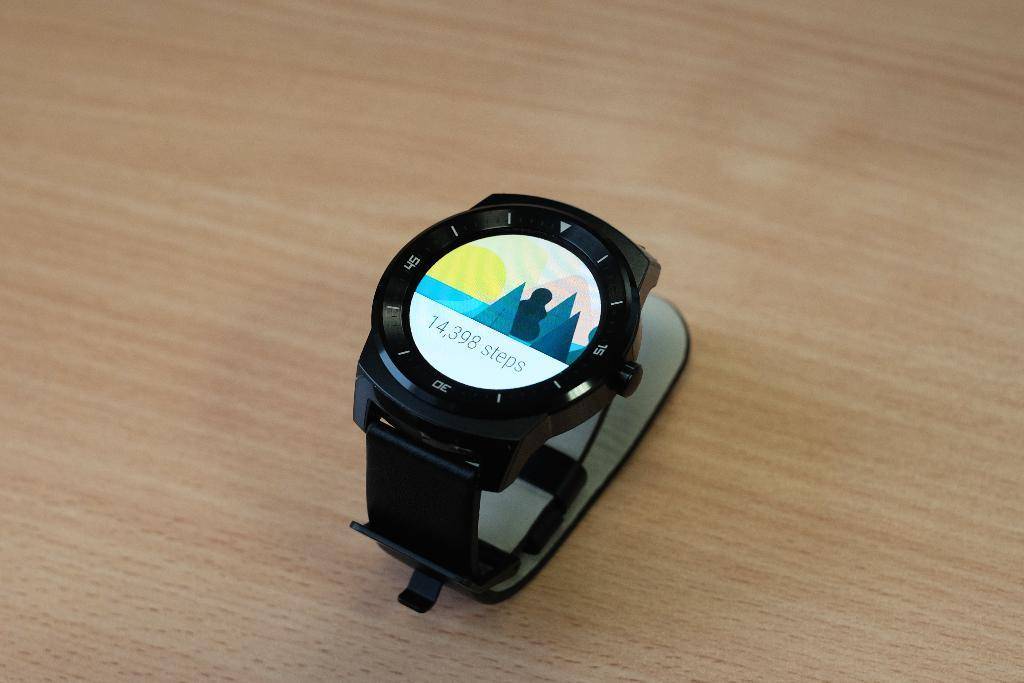<image>
Summarize the visual content of the image. The digital watch indicates that whoever was wearing it walked 14,398 steps 